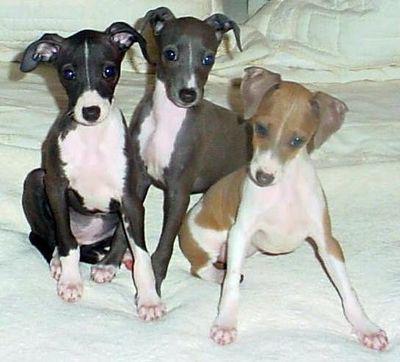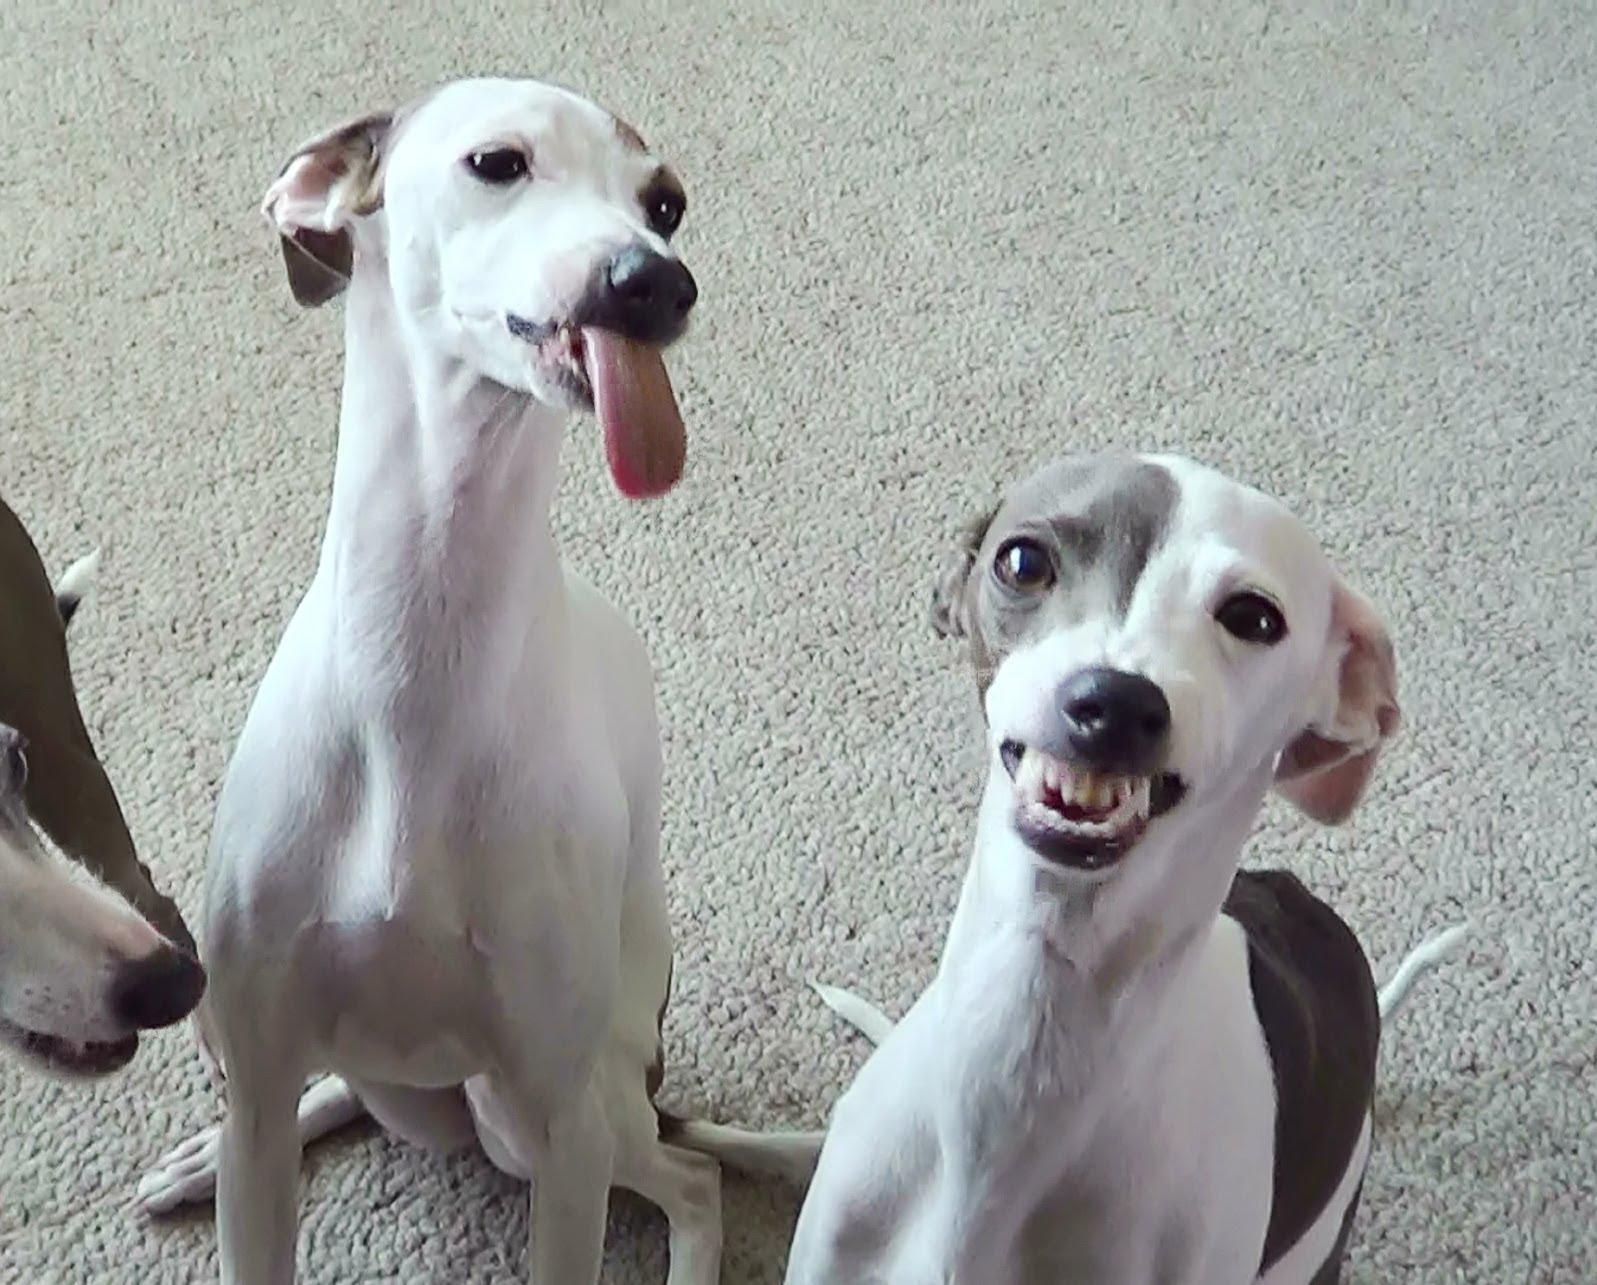The first image is the image on the left, the second image is the image on the right. Considering the images on both sides, is "One image shows one hound wearing attire besides a collar, and the other image shows at least one dog wearing just a collar." valid? Answer yes or no. No. The first image is the image on the left, the second image is the image on the right. For the images displayed, is the sentence "Three dogs are posing together in one of the images." factually correct? Answer yes or no. Yes. 